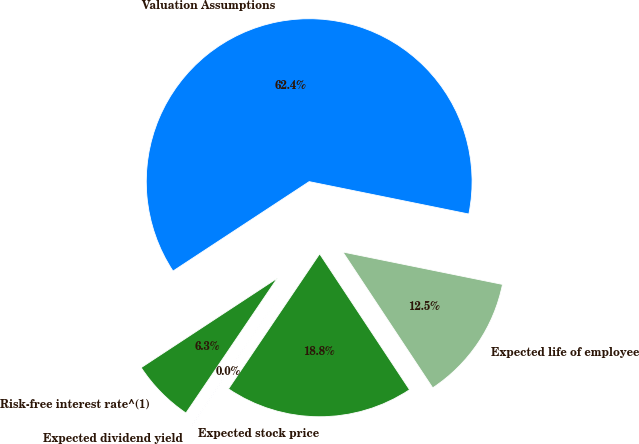<chart> <loc_0><loc_0><loc_500><loc_500><pie_chart><fcel>Valuation Assumptions<fcel>Risk-free interest rate^(1)<fcel>Expected dividend yield<fcel>Expected stock price<fcel>Expected life of employee<nl><fcel>62.43%<fcel>6.27%<fcel>0.03%<fcel>18.75%<fcel>12.51%<nl></chart> 